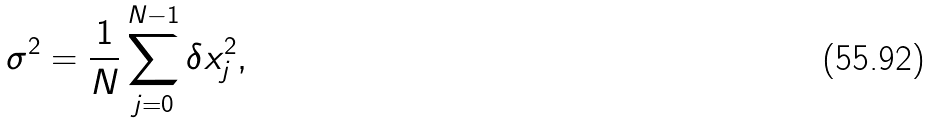<formula> <loc_0><loc_0><loc_500><loc_500>\sigma ^ { 2 } = \frac { 1 } { N } \sum _ { j = 0 } ^ { N - 1 } \delta x _ { j } ^ { 2 } ,</formula> 